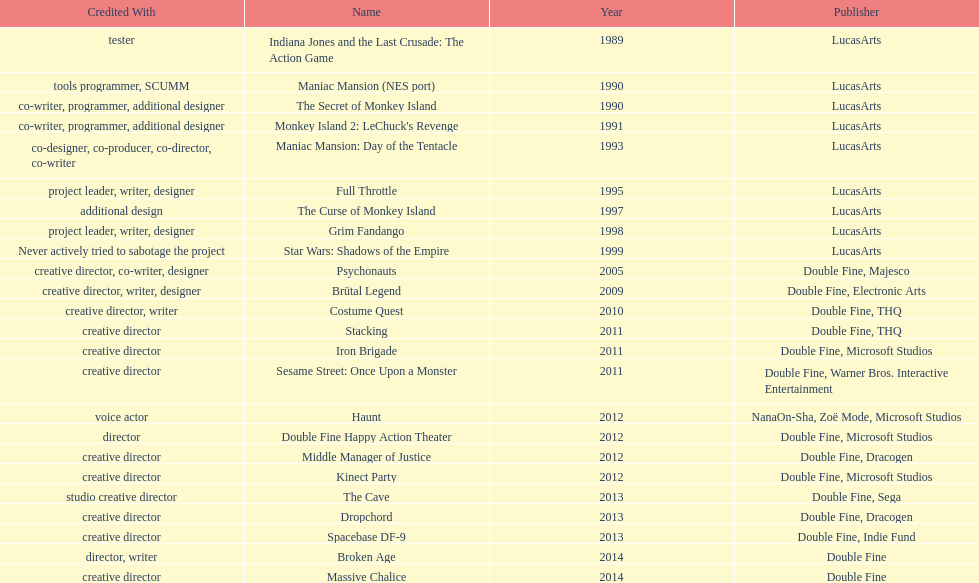How many games were credited with a creative director? 11. 